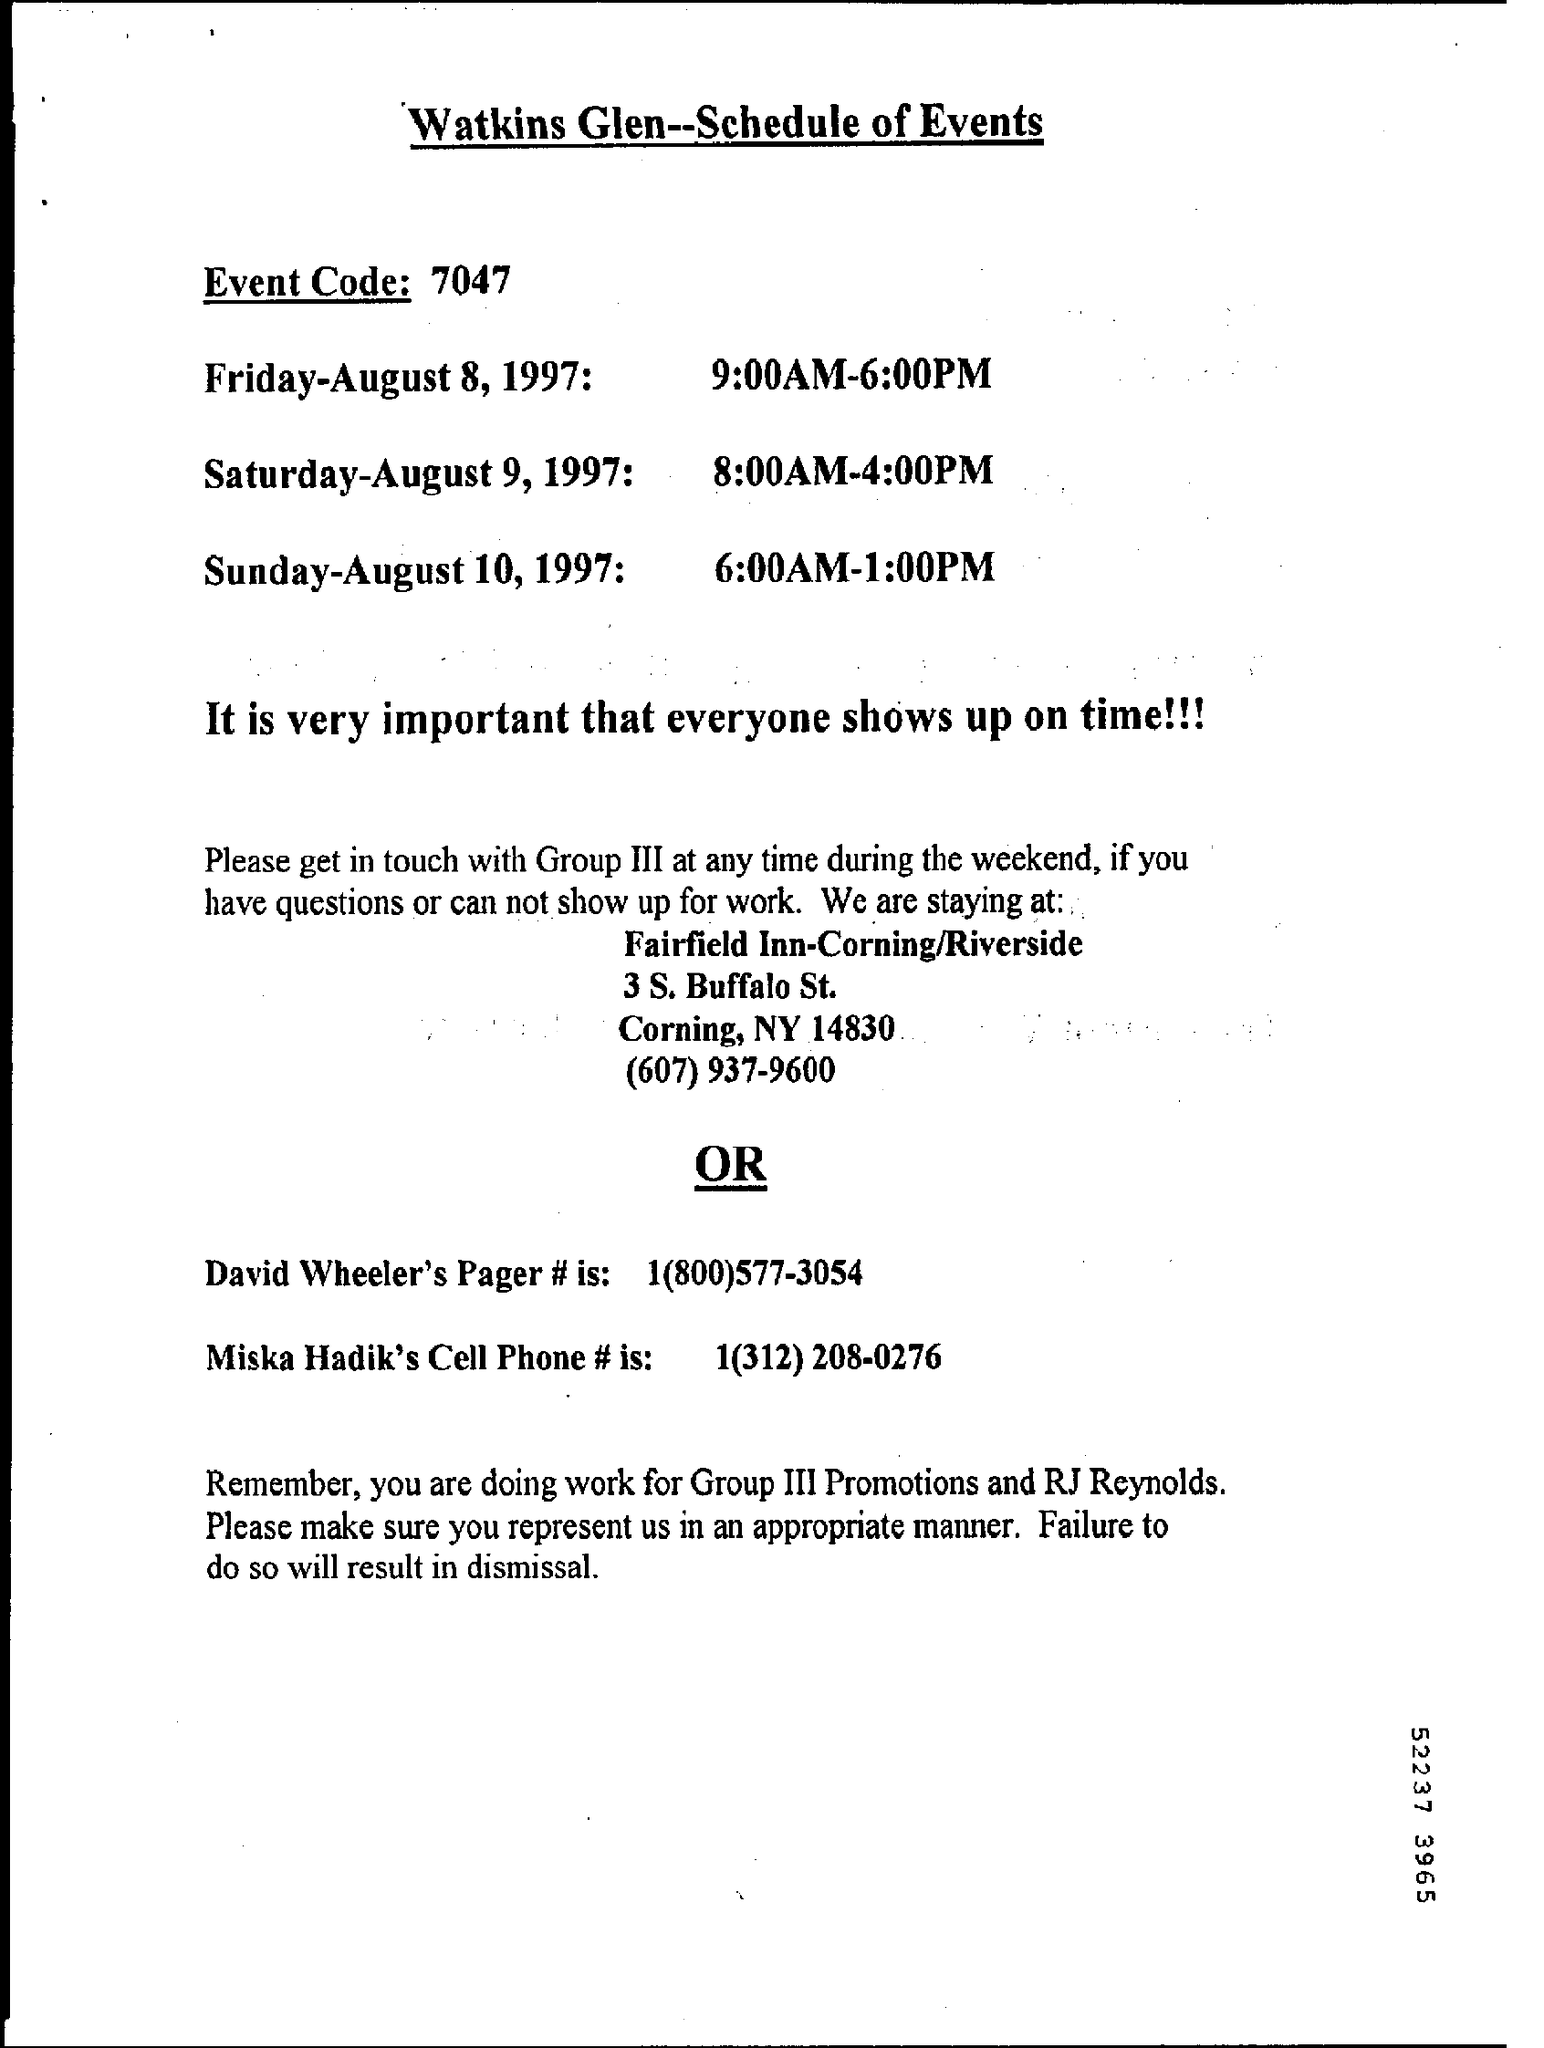What is the event code ?
Your answer should be compact. 7047. 